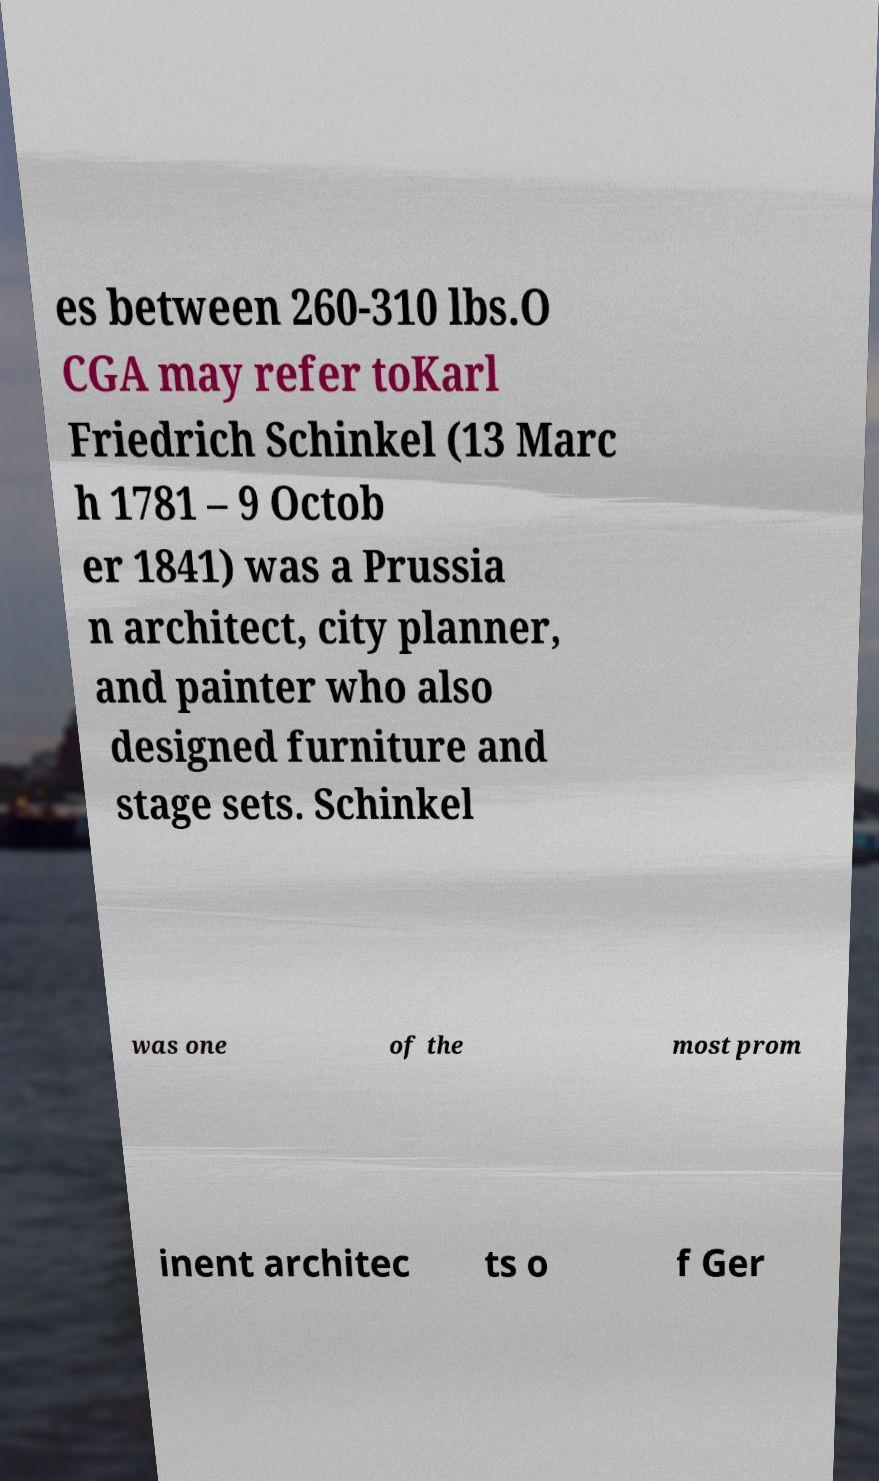Could you assist in decoding the text presented in this image and type it out clearly? es between 260-310 lbs.O CGA may refer toKarl Friedrich Schinkel (13 Marc h 1781 – 9 Octob er 1841) was a Prussia n architect, city planner, and painter who also designed furniture and stage sets. Schinkel was one of the most prom inent architec ts o f Ger 